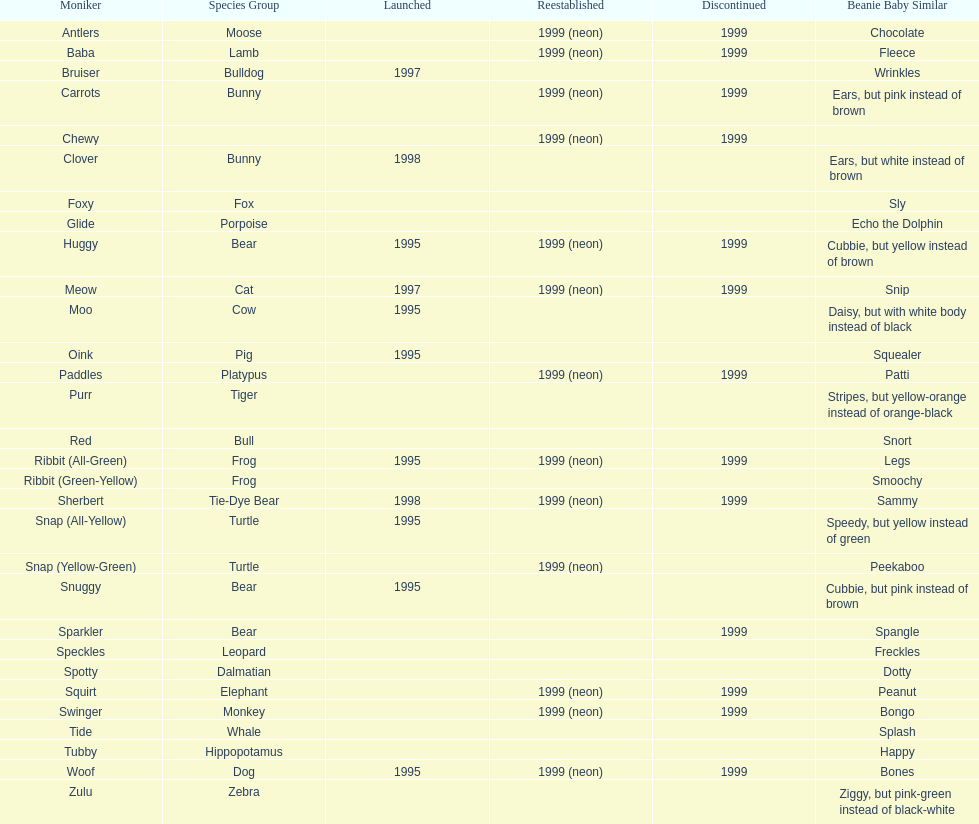Name the only pillow pal that is a dalmatian. Spotty. 